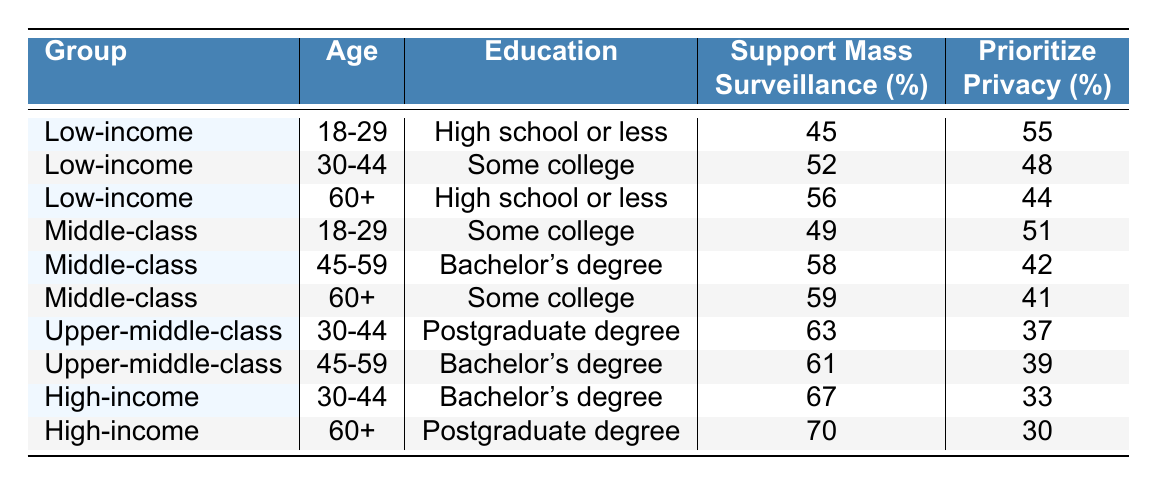What percentage of the Upper-middle-class aged 30-44 support mass surveillance? From the table, the Upper-middle-class group in the 30-44 age category has a value of 63% for supporting mass surveillance.
Answer: 63% Which socioeconomic group shows the highest support for mass surveillance? By examining the table, we can see that the High-income group aged 60+ has the highest percentage at 70%.
Answer: 70% How does the support for mass surveillance compare between Low-income individuals aged 18-29 and Middle-class individuals aged 18-29? The Low-income group aged 18-29 supports mass surveillance at 45%, while the Middle-class group supports it at 49%. The difference is 49% - 45% = 4%.
Answer: 4% Is it true that all age groups in the Low-income socioeconomic group prioritize privacy over mass surveillance? Checking each age category within the Low-income group, we find that those aged 30-44 support mass surveillance (52%) more than they prioritize privacy (48%). Therefore, the statement is false.
Answer: No What is the average support for mass surveillance across all education levels in the Middle-class socioeconomic group? To find the average, we need to sum the support values for the Middle-class group: 49% (18-29) + 58% (45-59) + 59% (60+) = 166%. There are three data points, so the average is 166% / 3 = 55.33%.
Answer: 55.33% What is the privacy prioritization percentage difference between the Upper-middle-class and High-income groups in the 30-44 age bracket? The Upper-middle-class prioritizes privacy at 37%, while the High-income group prioritizes privacy at 33%. The difference is 37% - 33% = 4%.
Answer: 4% Which socioeconomic group has the lowest priority for privacy among those aged 60+? The table shows that the High-income group aged 60+ has the lowest privacy prioritization at 30%.
Answer: 30% For individuals with a Bachelor's degree, which age group in the Upper-middle-class has a higher support for mass surveillance? The table lists the Upper-middle-class support at 61% for ages 45-59 and does not provide lower support for ages 30-44 (63%). Hence, the 30-44 age group has higher support.
Answer: 30-44 age group What total percentage of support for mass surveillance do the Low-income group members in the 60+ age category have versus the Middle-class group in the same age category? The Low-income group has a support percentage of 56% and the Middle-class group has 59%. The total is 56% + 59% = 115%.
Answer: 115% In which age group does the Middle-class socioeconomic group show the least support for mass surveillance? Referring to the table, the Middle-class group aged 18-29 shows the least support at 49%, compared to 58% and 59% for the other age categories.
Answer: 18-29 